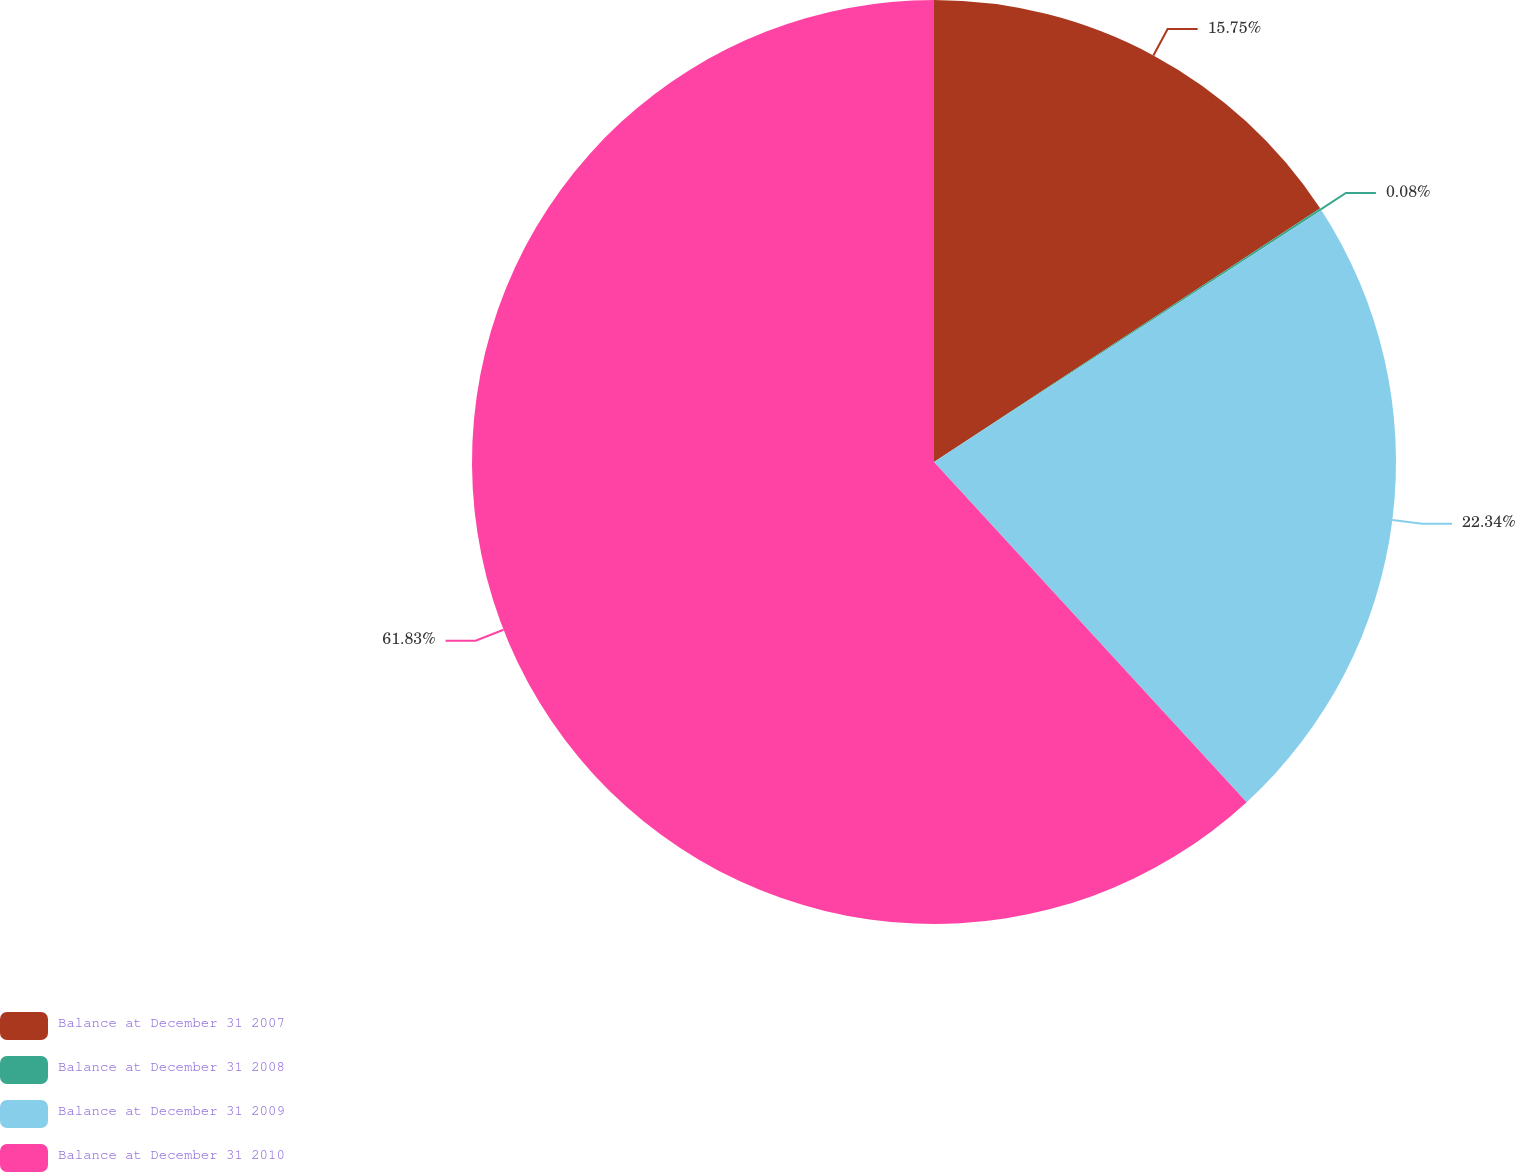Convert chart to OTSL. <chart><loc_0><loc_0><loc_500><loc_500><pie_chart><fcel>Balance at December 31 2007<fcel>Balance at December 31 2008<fcel>Balance at December 31 2009<fcel>Balance at December 31 2010<nl><fcel>15.75%<fcel>0.08%<fcel>22.34%<fcel>61.83%<nl></chart> 